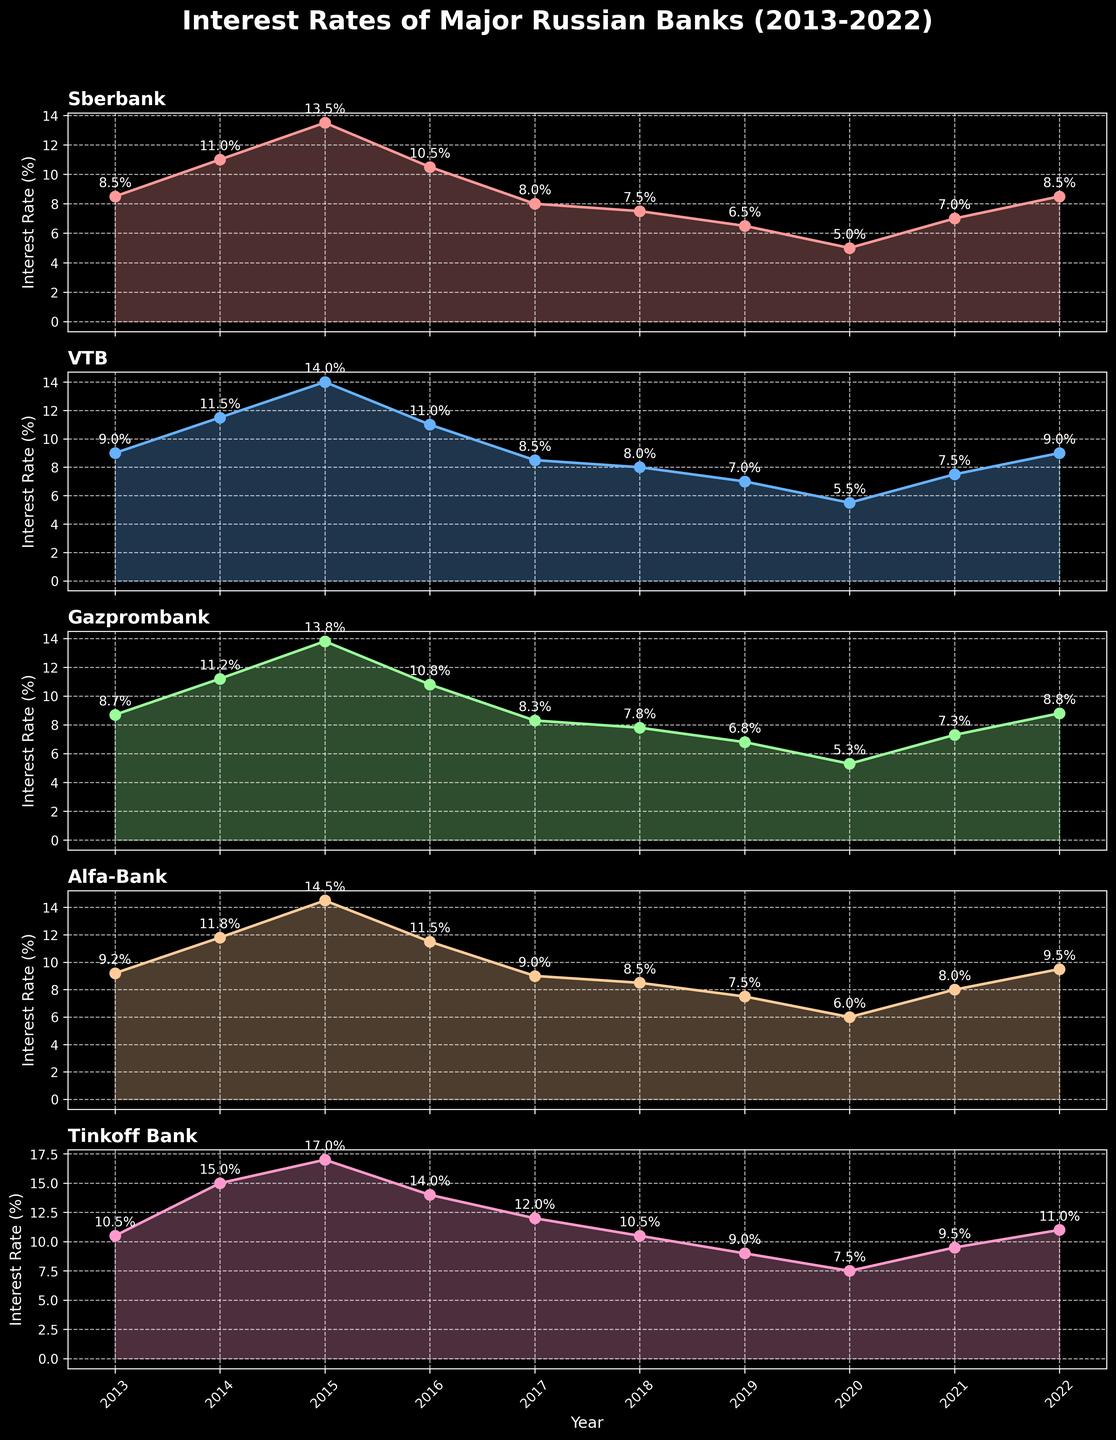What is the title of the figure? The title is located at the top of the figure in bold and larger font size. It provides a summary of what the figure is about.
Answer: Interest Rates of Major Russian Banks (2013-2022) How many banks are compared in the figure? We can determine the number of banks by looking at the number of horizontal subplots. Each subplot represents data for one bank.
Answer: 5 Which bank had the highest interest rate in 2014? By examining the point marked in 2014 across all subplots, we can see which bank's interest rate is highest. Tinkoff Bank shows the maximum value.
Answer: Tinkoff Bank What was the trend of Sberbank's interest rates from 2013 to 2022? By following the Sberbank subplot line from 2013 to 2022, we observe the changes in the data points. The trend starts high, peaks in 2015, drops until 2020, slightly increases, and then increases again till 2022.
Answer: Decreasing with fluctuations Between which years did Alfa-Bank experience its largest single-year drop in interest rates? Looking at Alfa-Bank's subplot, find the year with the largest vertical drop between consecutive data points by comparing the difference year-by-year.
Answer: 2015-2016 Which bank had the lowest interest rate in 2020? Identify the 2020 data point on each subplot, then determine which one is the lowest. Sberbank shows the lowest value in 2020.
Answer: Sberbank What is the difference in interest rate between Sberbank and Gazprombank in 2019? Locate the 2019 data points for both Sberbank and Gazprombank and subtract the smaller value from the larger value. The interest rate for Sberbank in 2019 is 6.5% and for Gazprombank is 6.8%.
Answer: 0.3% Compare the average interest rates of VTB and Tinkoff Bank over the decade. Calculate the average interest rate for both banks over the given years by summing each bank's annual interest rates and dividing by the number of years (10).
Answer: VTB: 9.9%, Tinkoff Bank: 11.6% Which bank showed the most stable interest rates over the decade? To determine stability, look for the subplot with the least variation in its line. Sberbank's line has the least fluctuations compared to others.
Answer: Sberbank 